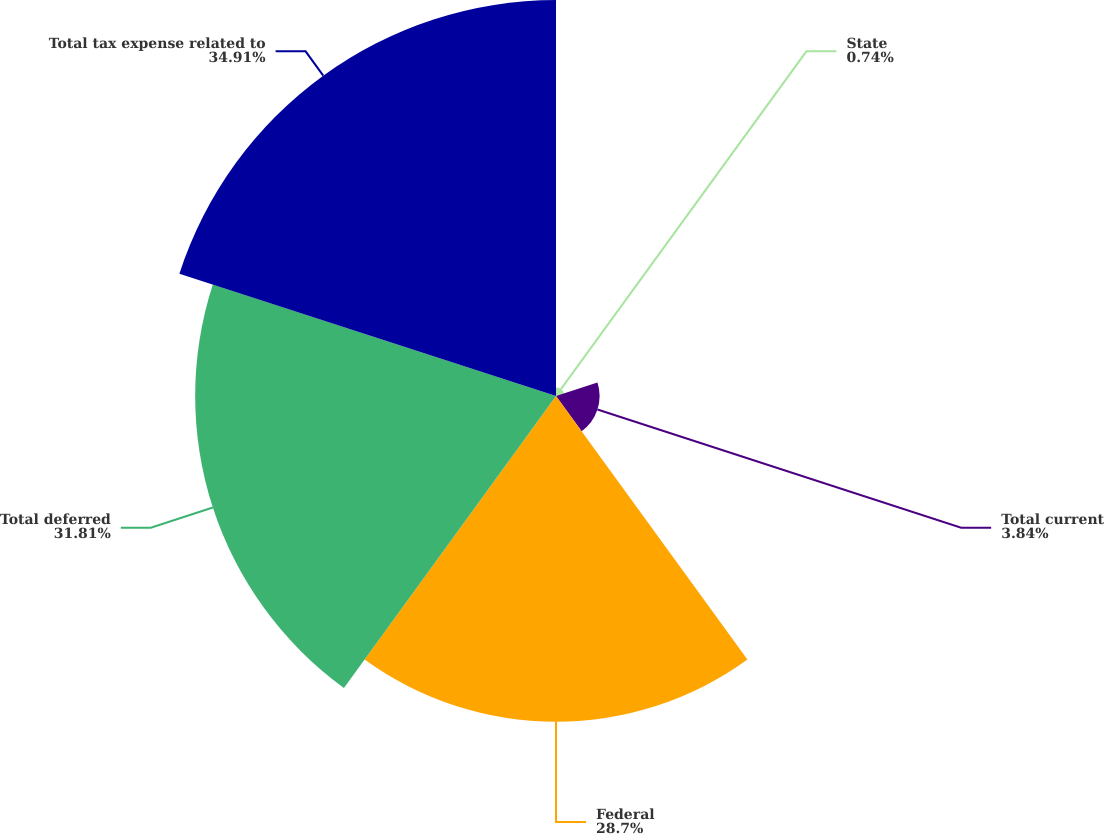Convert chart to OTSL. <chart><loc_0><loc_0><loc_500><loc_500><pie_chart><fcel>State<fcel>Total current<fcel>Federal<fcel>Total deferred<fcel>Total tax expense related to<nl><fcel>0.74%<fcel>3.84%<fcel>28.7%<fcel>31.8%<fcel>34.9%<nl></chart> 